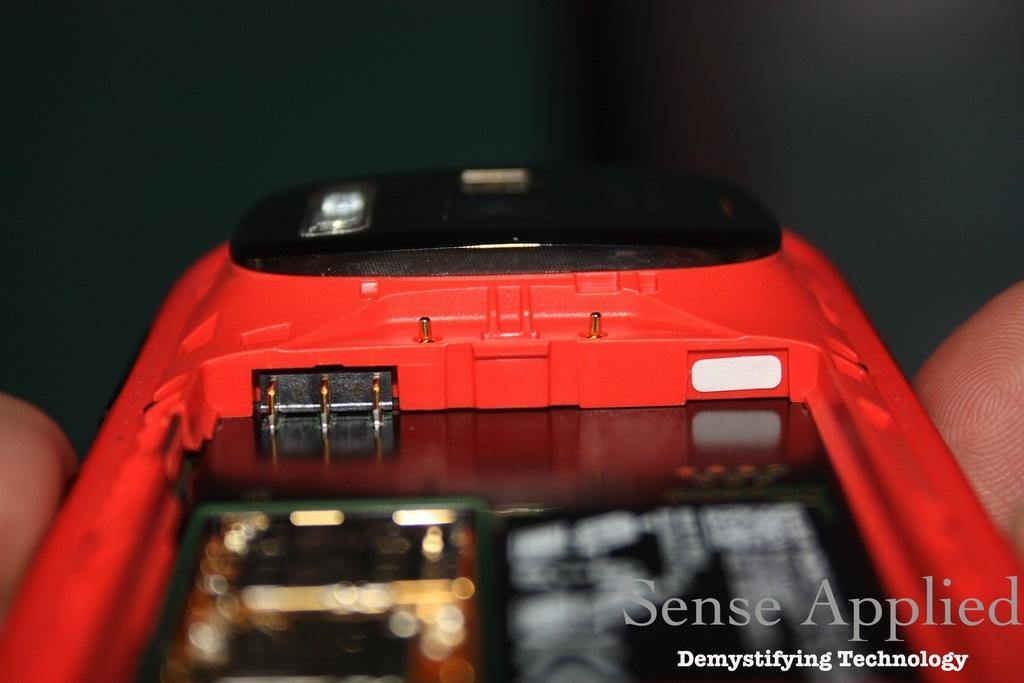Provide a one-sentence caption for the provided image. A close up of a red cell phone taken apart by Sense Applied. 